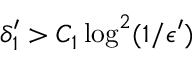Convert formula to latex. <formula><loc_0><loc_0><loc_500><loc_500>\delta _ { 1 } ^ { \prime } > C _ { 1 } \log ^ { 2 } ( 1 / \epsilon ^ { \prime } )</formula> 